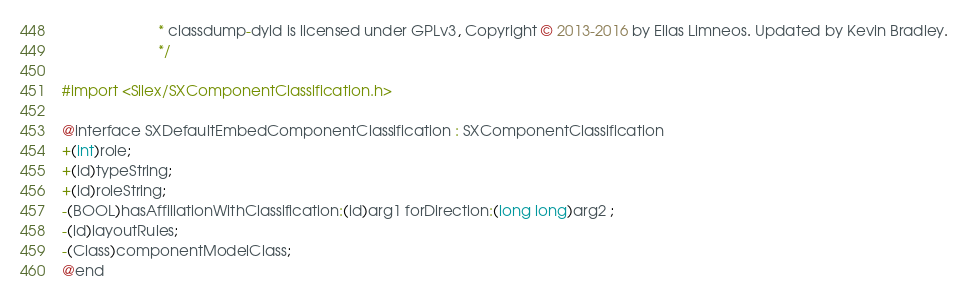<code> <loc_0><loc_0><loc_500><loc_500><_C_>                       * classdump-dyld is licensed under GPLv3, Copyright © 2013-2016 by Elias Limneos. Updated by Kevin Bradley.
                       */

#import <Silex/SXComponentClassification.h>

@interface SXDefaultEmbedComponentClassification : SXComponentClassification
+(int)role;
+(id)typeString;
+(id)roleString;
-(BOOL)hasAffiliationWithClassification:(id)arg1 forDirection:(long long)arg2 ;
-(id)layoutRules;
-(Class)componentModelClass;
@end

</code> 